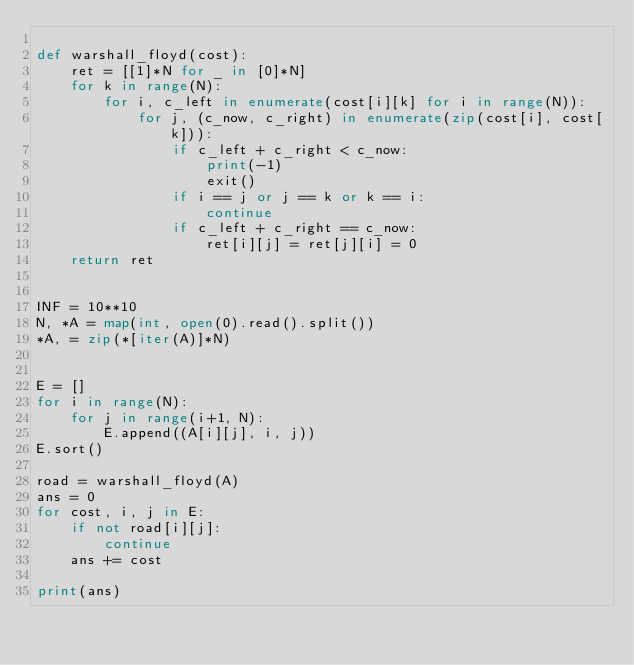Convert code to text. <code><loc_0><loc_0><loc_500><loc_500><_Python_>
def warshall_floyd(cost):
    ret = [[1]*N for _ in [0]*N]
    for k in range(N):
        for i, c_left in enumerate(cost[i][k] for i in range(N)):
            for j, (c_now, c_right) in enumerate(zip(cost[i], cost[k])):
                if c_left + c_right < c_now:
                    print(-1)
                    exit()
                if i == j or j == k or k == i:
                    continue
                if c_left + c_right == c_now:
                    ret[i][j] = ret[j][i] = 0
    return ret


INF = 10**10
N, *A = map(int, open(0).read().split())
*A, = zip(*[iter(A)]*N)


E = []
for i in range(N):
    for j in range(i+1, N):
        E.append((A[i][j], i, j))
E.sort()

road = warshall_floyd(A)
ans = 0
for cost, i, j in E:
    if not road[i][j]:
        continue
    ans += cost

print(ans)
</code> 